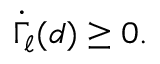Convert formula to latex. <formula><loc_0><loc_0><loc_500><loc_500>\begin{array} { r } { \dot { \Gamma } _ { \ell } ( d ) \geq 0 . } \end{array}</formula> 